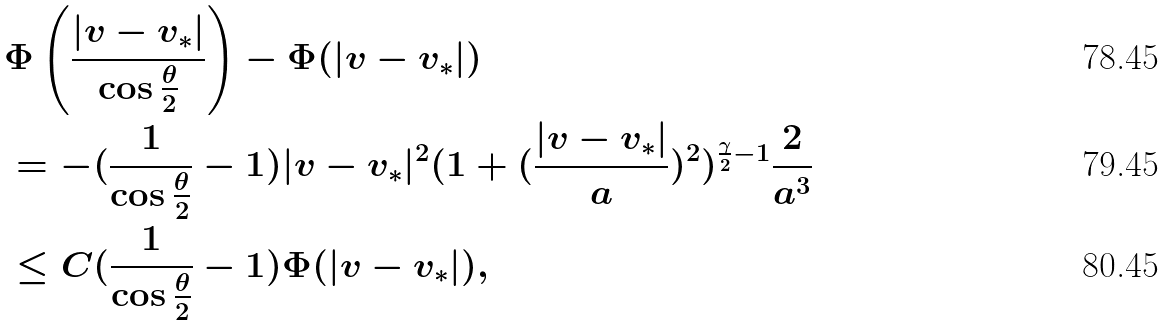Convert formula to latex. <formula><loc_0><loc_0><loc_500><loc_500>& \Phi \left ( \frac { | v - v _ { * } | } { \cos \frac { \theta } { 2 } } \right ) - \Phi ( | v - v _ { * } | ) \\ & = - ( \frac { 1 } { \cos \frac { \theta } { 2 } } - 1 ) | v - v _ { * } | ^ { 2 } ( 1 + ( \frac { | v - v _ { * } | } { a } ) ^ { 2 } ) ^ { \frac { \gamma } { 2 } - 1 } \frac { 2 } { a ^ { 3 } } \\ & \leq C ( \frac { 1 } { \cos \frac { \theta } { 2 } } - 1 ) \Phi ( | v - v _ { * } | ) ,</formula> 